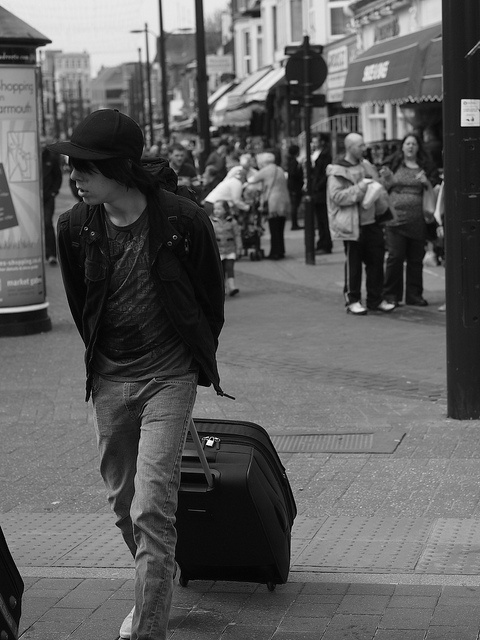Describe the objects in this image and their specific colors. I can see people in lightgray, black, and gray tones, suitcase in lightgray, black, and gray tones, people in lightgray, black, gray, and darkgray tones, people in lightgray, black, gray, and darkgray tones, and people in lightgray, gray, black, and darkgray tones in this image. 